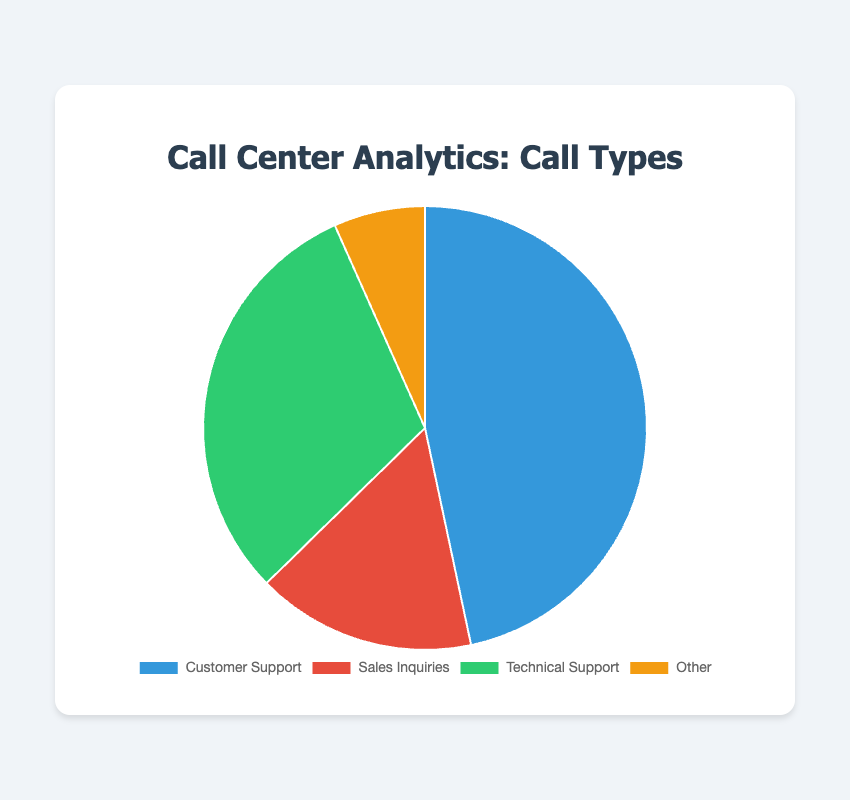What's the most common type of call received at the call center? The pie chart shows the largest segment is labeled "Customer Support," indicating that it receives the most calls.
Answer: Customer Support Which type of call makes up the smallest percentage of the total calls? The smallest segment in the pie chart is labeled "Other," indicating it has the fewest calls.
Answer: Other How many more Customer Support calls are there compared to Sales Inquiries? Customer Support has 350 calls and Sales Inquiries has 120 calls. The difference is 350 - 120 = 230 calls.
Answer: 230 What percentage of the total calls are for Technical Support? Technical Support has 230 calls. The total number of calls is 350 (Customer Support) + 120 (Sales Inquiries) + 230 (Technical Support) + 50 (Other) = 750. The percentage is (230 / 750) * 100 ≈ 30.67%.
Answer: 30.67% Are the number of Technical Support calls greater than the number of Sales Inquiries and Other combined? Technical Support has 230 calls. Sales Inquiries and Other together have 120 + 50 = 170 calls. Since 230 > 170, Technical Support has more calls.
Answer: Yes What is the ratio of Customer Support calls to Technical Support calls? Customer Support has 350 calls and Technical Support has 230 calls. The ratio is 350:230, which simplifies to 35:23.
Answer: 35:23 Which type of call has a segment colored in red in the pie chart? The segment for Sales Inquiries is colored red in the pie chart, as indicated by the legend.
Answer: Sales Inquiries How many calls do the Customer Support and Technical Support categories receive combined? Customer Support has 350 calls and Technical Support has 230 calls. Combined, they have 350 + 230 = 580 calls.
Answer: 580 What is the average number of calls per type? The total number of calls is 750, and there are 4 types. The average is 750 / 4 = 187.5 calls per type.
Answer: 187.5 What is the difference in percentage between Customer Support and the least common call type? Customer Support has 350 calls out of 750 total, i.e., (350 / 750) * 100 ≈ 46.67%. The least common type is Other with (50 / 750) * 100 ≈ 6.67%. The difference is 46.67% - 6.67% = 40%.
Answer: 40% 